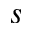Convert formula to latex. <formula><loc_0><loc_0><loc_500><loc_500>s</formula> 